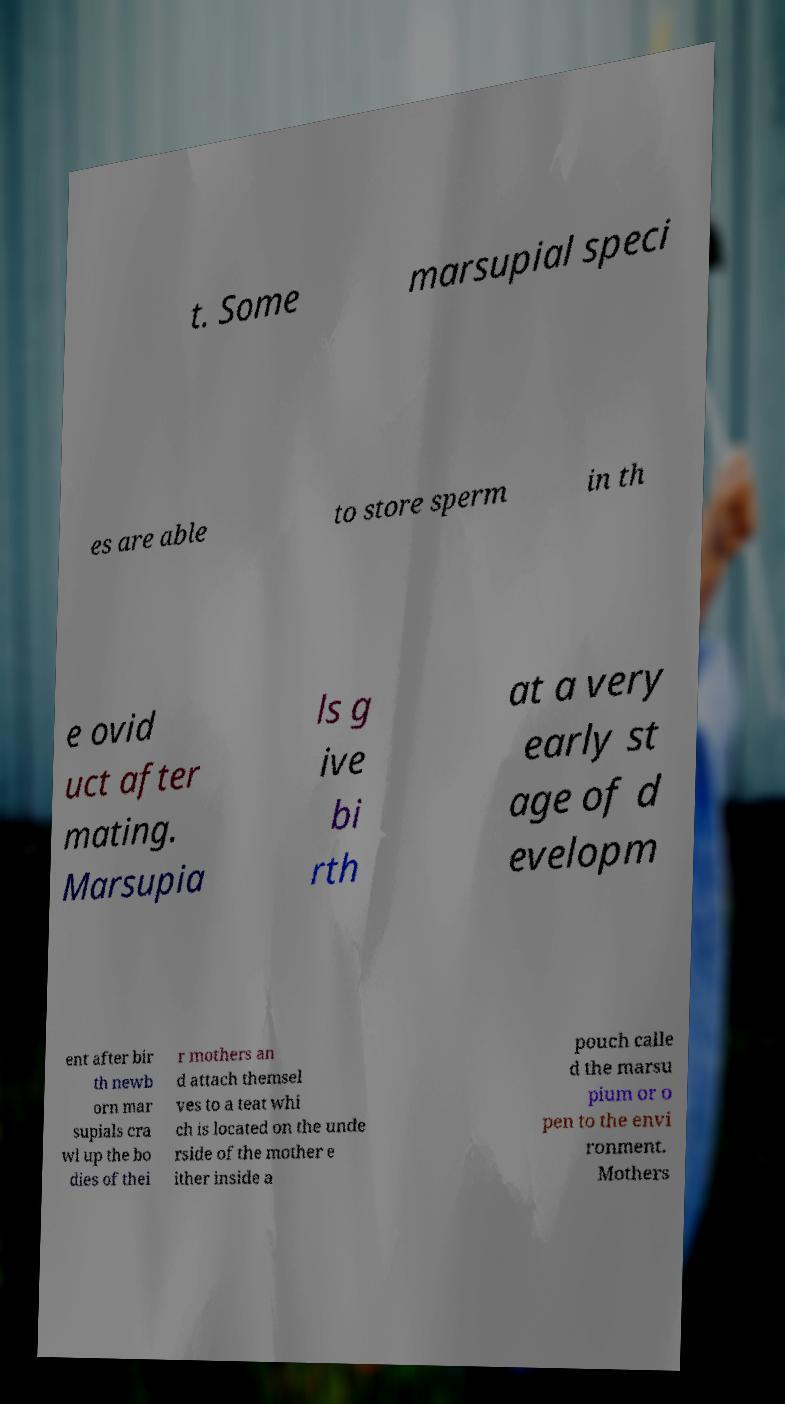There's text embedded in this image that I need extracted. Can you transcribe it verbatim? t. Some marsupial speci es are able to store sperm in th e ovid uct after mating. Marsupia ls g ive bi rth at a very early st age of d evelopm ent after bir th newb orn mar supials cra wl up the bo dies of thei r mothers an d attach themsel ves to a teat whi ch is located on the unde rside of the mother e ither inside a pouch calle d the marsu pium or o pen to the envi ronment. Mothers 